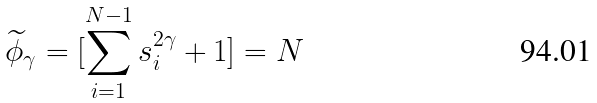<formula> <loc_0><loc_0><loc_500><loc_500>\widetilde { \phi } _ { \gamma } = [ \sum _ { i = 1 } ^ { N - 1 } s _ { i } ^ { 2 \gamma } + 1 ] = N</formula> 